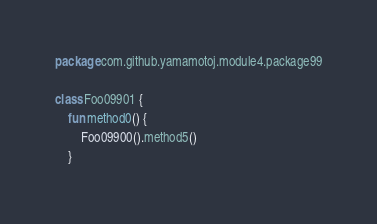Convert code to text. <code><loc_0><loc_0><loc_500><loc_500><_Kotlin_>package com.github.yamamotoj.module4.package99

class Foo09901 {
    fun method0() {
        Foo09900().method5()
    }
</code> 